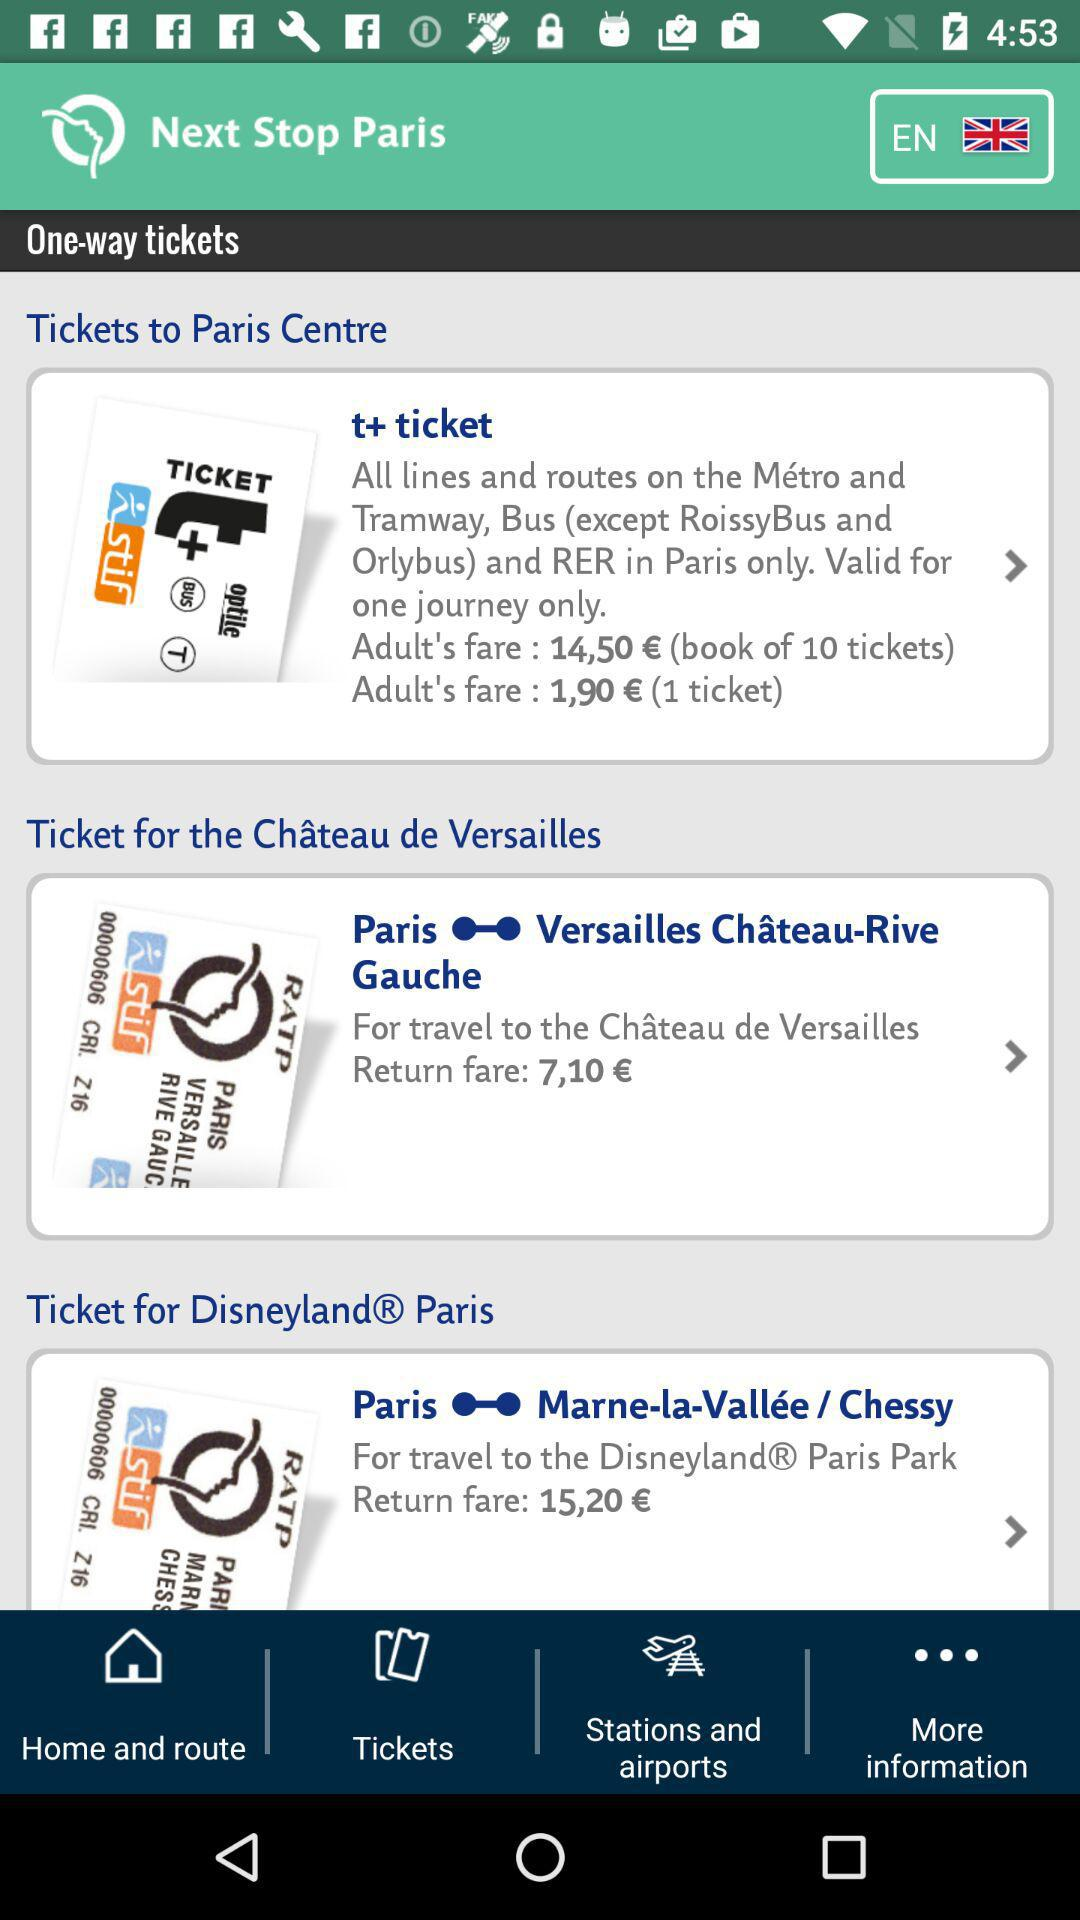How many tickets are in a book of t+ tickets?
Answer the question using a single word or phrase. 10 